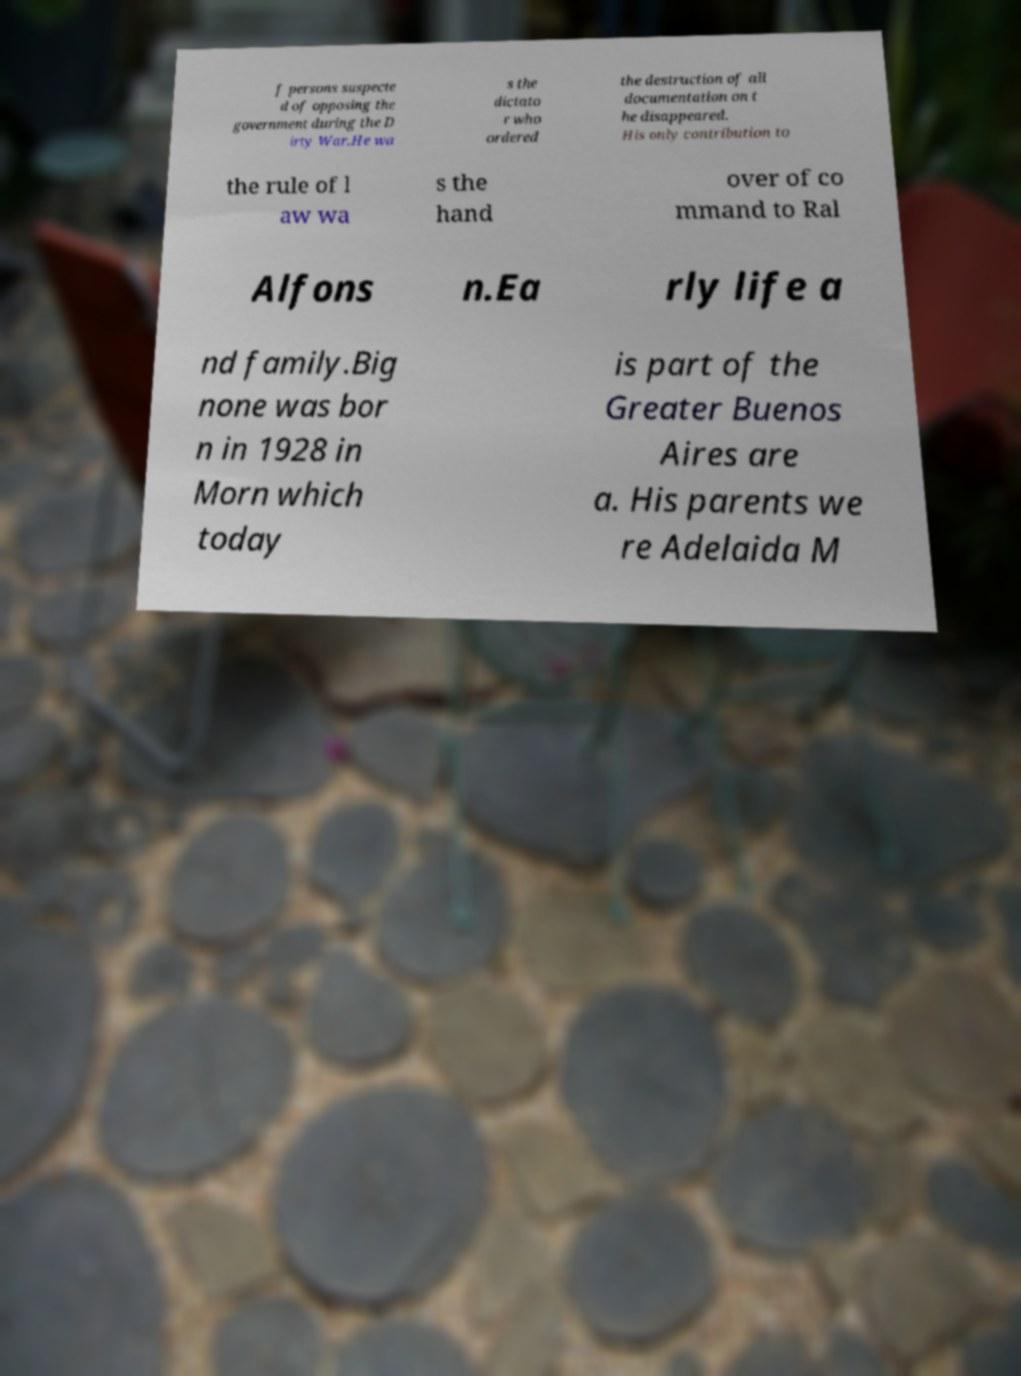Please identify and transcribe the text found in this image. f persons suspecte d of opposing the government during the D irty War.He wa s the dictato r who ordered the destruction of all documentation on t he disappeared. His only contribution to the rule of l aw wa s the hand over of co mmand to Ral Alfons n.Ea rly life a nd family.Big none was bor n in 1928 in Morn which today is part of the Greater Buenos Aires are a. His parents we re Adelaida M 